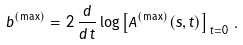<formula> <loc_0><loc_0><loc_500><loc_500>b ^ { ( \max ) } = 2 \, \frac { d } { d \, t } \log \left [ A ^ { ( \max ) } ( s , t ) \right ] _ { \, t = 0 } \, .</formula> 